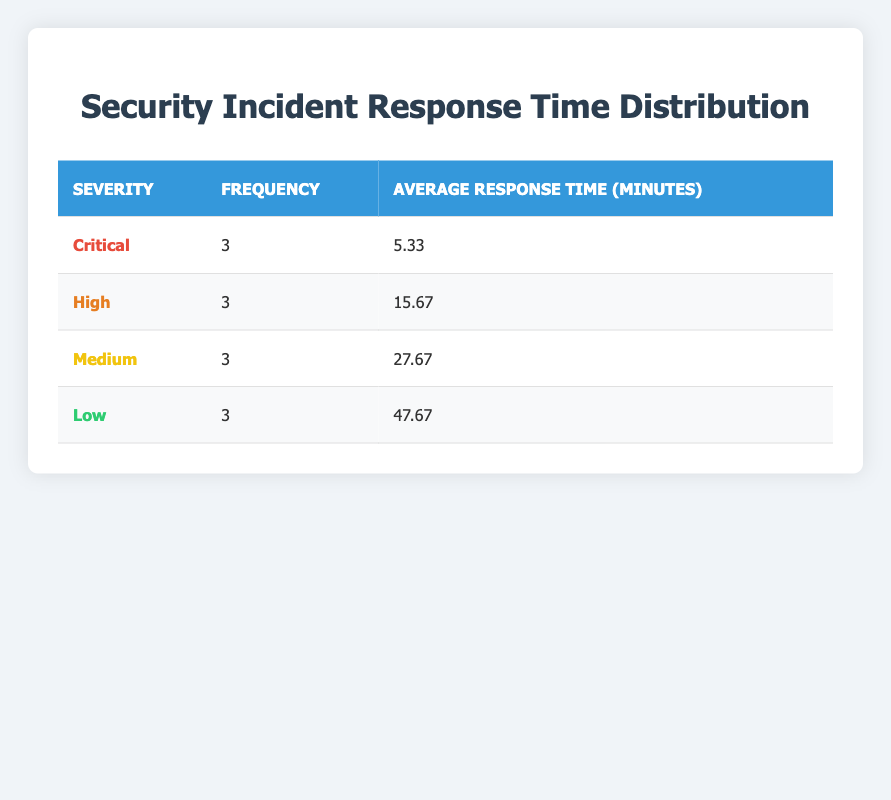What is the frequency of critical severity incidents? The table shows that the frequency for critical severity incidents is listed under the "Frequency" column for "Critical," which is 3.
Answer: 3 What is the average response time for low severity incidents? To find the average response time for low severity, look under the "Average Response Time (minutes)" column for "Low," which is 47.67.
Answer: 47.67 How many incidents have a severity level of high? The table states that the total frequency for high severity incidents, found in the corresponding column, is 3.
Answer: 3 What is the difference between the average response time for medium and high severity incidents? The average response time for medium severity incidents is 27.67 minutes, while for high severity it is 15.67 minutes. The difference is 27.67 - 15.67 = 12 minutes.
Answer: 12 Is the average response time for critical incidents greater than the average response time for medium incidents? The average response time for critical incidents is 5.33 minutes, which is not greater than the average response time for medium incidents, which is 27.67 minutes. Therefore, the statement is false.
Answer: No What is the total number of security incidents across all severities? To calculate the total number of incidents, sum the frequency of each severity: 3 (Critical) + 3 (High) + 3 (Medium) + 3 (Low) = 12 total incidents.
Answer: 12 Which severity level has the highest average response time? By comparing the average response times, we notice that "Low" has the highest average response time of 47.67 minutes when checked against the other severity levels.
Answer: Low Is the average response time for high severity incidents less than the average response time for critical incidents? The average response time for high incidents is 15.67 minutes, which is more than 5.33 minutes for critical incidents, so this statement is false.
Answer: No What is the sum of average response times for all severity levels? To find the sum, we calculate: 5.33 (Critical) + 15.67 (High) + 27.67 (Medium) + 47.67 (Low) = 96.34 minutes.
Answer: 96.34 